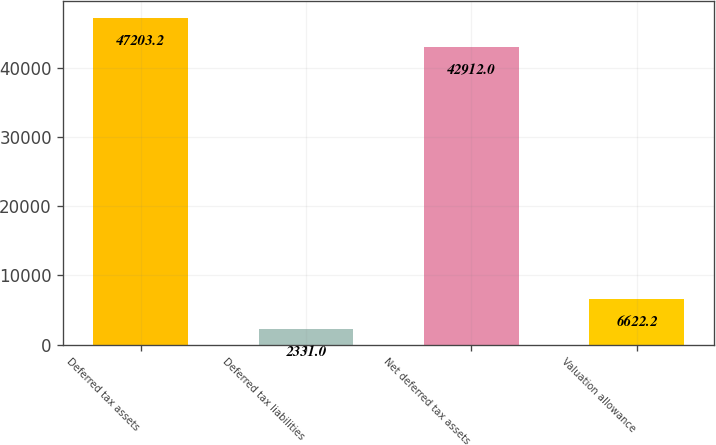Convert chart. <chart><loc_0><loc_0><loc_500><loc_500><bar_chart><fcel>Deferred tax assets<fcel>Deferred tax liabilities<fcel>Net deferred tax assets<fcel>Valuation allowance<nl><fcel>47203.2<fcel>2331<fcel>42912<fcel>6622.2<nl></chart> 